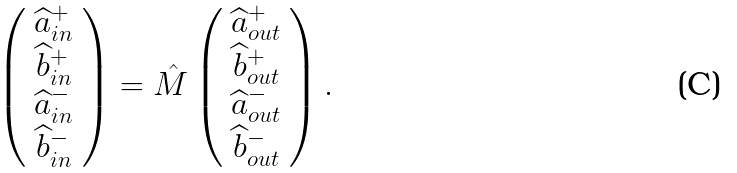<formula> <loc_0><loc_0><loc_500><loc_500>\left ( \begin{array} { c } \widehat { a } _ { i n } ^ { + } \\ \widehat { b } _ { i n } ^ { + } \\ \widehat { a } _ { i n } ^ { - } \\ \widehat { b } _ { i n } ^ { - } \end{array} \right ) = \hat { M } \left ( \begin{array} { c } \widehat { a } _ { o u t } ^ { + } \\ \widehat { b } _ { o u t } ^ { + } \\ \widehat { a } _ { o u t } ^ { - } \\ \widehat { b } _ { o u t } ^ { - } \end{array} \right ) .</formula> 